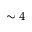<formula> <loc_0><loc_0><loc_500><loc_500>\sim 4</formula> 